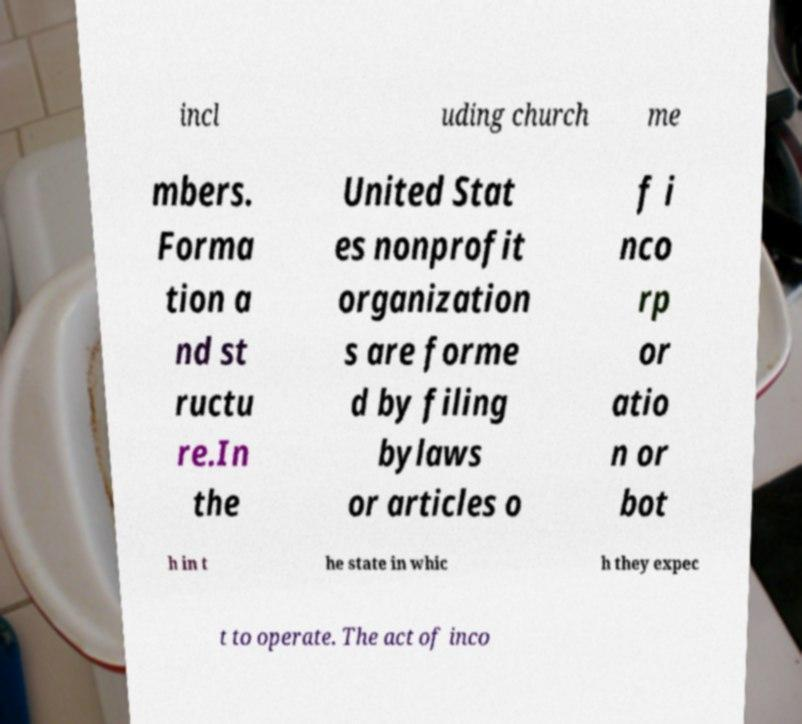Please identify and transcribe the text found in this image. incl uding church me mbers. Forma tion a nd st ructu re.In the United Stat es nonprofit organization s are forme d by filing bylaws or articles o f i nco rp or atio n or bot h in t he state in whic h they expec t to operate. The act of inco 